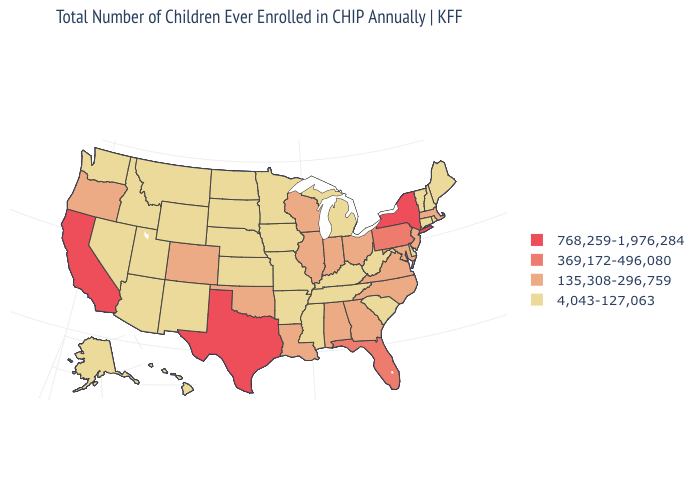What is the highest value in states that border Michigan?
Quick response, please. 135,308-296,759. Which states have the lowest value in the USA?
Answer briefly. Alaska, Arizona, Arkansas, Connecticut, Delaware, Hawaii, Idaho, Iowa, Kansas, Kentucky, Maine, Michigan, Minnesota, Mississippi, Missouri, Montana, Nebraska, Nevada, New Hampshire, New Mexico, North Dakota, Rhode Island, South Carolina, South Dakota, Tennessee, Utah, Vermont, Washington, West Virginia, Wyoming. Name the states that have a value in the range 135,308-296,759?
Be succinct. Alabama, Colorado, Georgia, Illinois, Indiana, Louisiana, Maryland, Massachusetts, New Jersey, North Carolina, Ohio, Oklahoma, Oregon, Virginia, Wisconsin. Does California have the highest value in the West?
Quick response, please. Yes. What is the highest value in the USA?
Quick response, please. 768,259-1,976,284. What is the value of New Jersey?
Short answer required. 135,308-296,759. Does Indiana have the lowest value in the MidWest?
Be succinct. No. Which states have the lowest value in the MidWest?
Be succinct. Iowa, Kansas, Michigan, Minnesota, Missouri, Nebraska, North Dakota, South Dakota. Which states have the lowest value in the West?
Be succinct. Alaska, Arizona, Hawaii, Idaho, Montana, Nevada, New Mexico, Utah, Washington, Wyoming. What is the value of North Carolina?
Answer briefly. 135,308-296,759. What is the value of Massachusetts?
Short answer required. 135,308-296,759. What is the value of Arkansas?
Answer briefly. 4,043-127,063. Name the states that have a value in the range 768,259-1,976,284?
Short answer required. California, New York, Texas. What is the value of Nebraska?
Give a very brief answer. 4,043-127,063. Does Indiana have a lower value than Arkansas?
Give a very brief answer. No. 